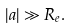Convert formula to latex. <formula><loc_0><loc_0><loc_500><loc_500>| a | \gg R _ { e } .</formula> 